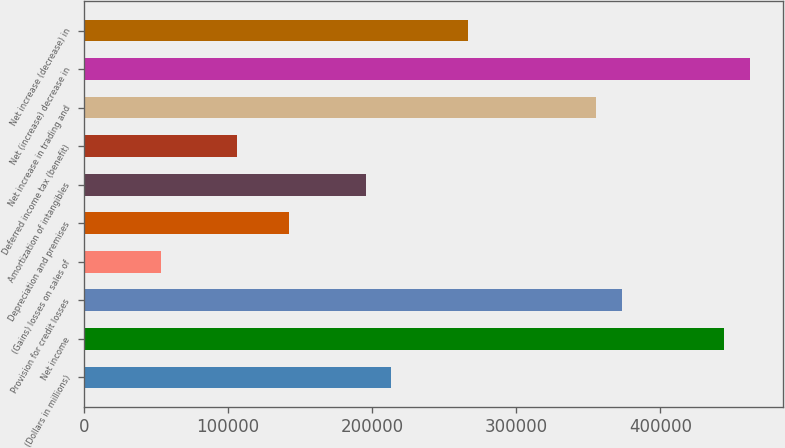<chart> <loc_0><loc_0><loc_500><loc_500><bar_chart><fcel>(Dollars in millions)<fcel>Net income<fcel>Provision for credit losses<fcel>(Gains) losses on sales of<fcel>Depreciation and premises<fcel>Amortization of intangibles<fcel>Deferred income tax (benefit)<fcel>Net increase in trading and<fcel>Net (increase) decrease in<fcel>Net increase (decrease) in<nl><fcel>213190<fcel>444106<fcel>373055<fcel>53326.1<fcel>142140<fcel>195428<fcel>106614<fcel>355292<fcel>461868<fcel>266478<nl></chart> 